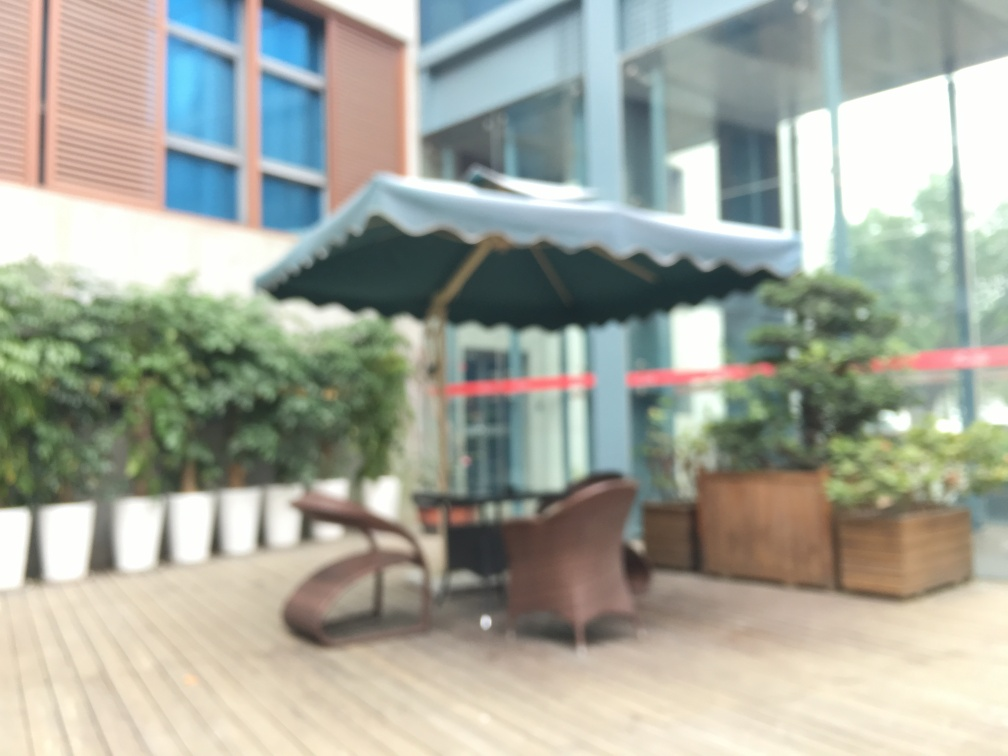What kind of establishment does this blurry image seem to show? Despite the blur, the image seems to depict an outdoor seating area of a café or restaurant, indicated by the presence of tables and chairs. 